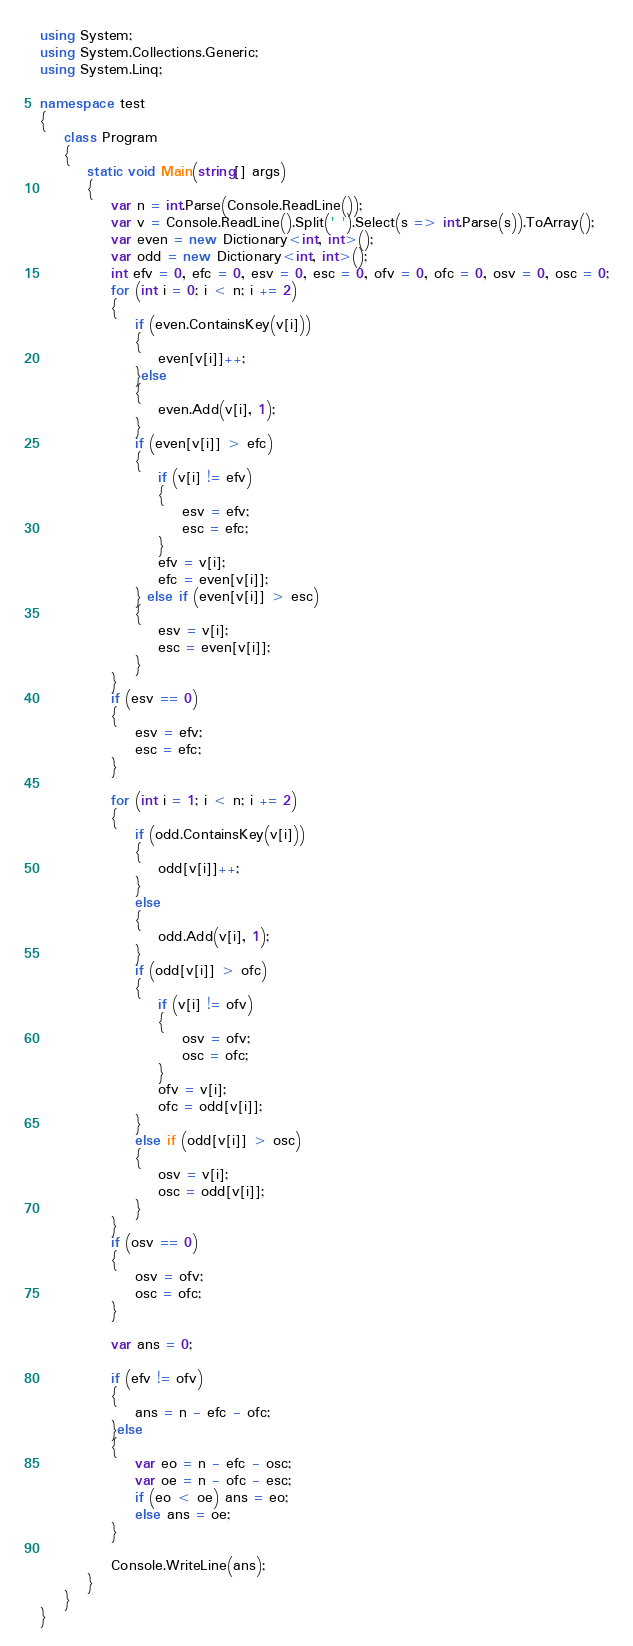Convert code to text. <code><loc_0><loc_0><loc_500><loc_500><_C#_>using System;
using System.Collections.Generic;
using System.Linq;

namespace test
{
    class Program
    {
        static void Main(string[] args)
        {
            var n = int.Parse(Console.ReadLine());
            var v = Console.ReadLine().Split(' ').Select(s => int.Parse(s)).ToArray();
            var even = new Dictionary<int, int>();
            var odd = new Dictionary<int, int>();
            int efv = 0, efc = 0, esv = 0, esc = 0, ofv = 0, ofc = 0, osv = 0, osc = 0;
            for (int i = 0; i < n; i += 2)
            {
                if (even.ContainsKey(v[i]))
                {
                    even[v[i]]++;
                }else
                {
                    even.Add(v[i], 1);
                }
                if (even[v[i]] > efc)
                {
                    if (v[i] != efv)
                    {
                        esv = efv;
                        esc = efc;
                    }
                    efv = v[i];
                    efc = even[v[i]];
                } else if (even[v[i]] > esc)
                {
                    esv = v[i];
                    esc = even[v[i]];
                }
            }
            if (esv == 0)
            {
                esv = efv;
                esc = efc;
            }

            for (int i = 1; i < n; i += 2)
            {
                if (odd.ContainsKey(v[i]))
                {
                    odd[v[i]]++;
                }
                else
                {
                    odd.Add(v[i], 1);
                }
                if (odd[v[i]] > ofc)
                {
                    if (v[i] != ofv)
                    {
                        osv = ofv;
                        osc = ofc;
                    }                    
                    ofv = v[i];
                    ofc = odd[v[i]];
                }
                else if (odd[v[i]] > osc)
                {
                    osv = v[i];
                    osc = odd[v[i]];
                }
            }
            if (osv == 0)
            {
                osv = ofv;
                osc = ofc;
            }

            var ans = 0;

            if (efv != ofv)
            {
                ans = n - efc - ofc;
            }else
            {
                var eo = n - efc - osc;
                var oe = n - ofc - esc;
                if (eo < oe) ans = eo;
                else ans = oe;
            }

            Console.WriteLine(ans);
        }
    }
}</code> 